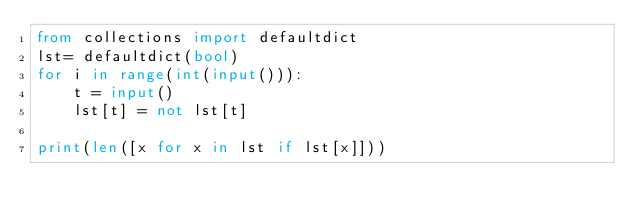<code> <loc_0><loc_0><loc_500><loc_500><_Python_>from collections import defaultdict
lst= defaultdict(bool)
for i in range(int(input())):
    t = input()
    lst[t] = not lst[t]

print(len([x for x in lst if lst[x]]))
</code> 